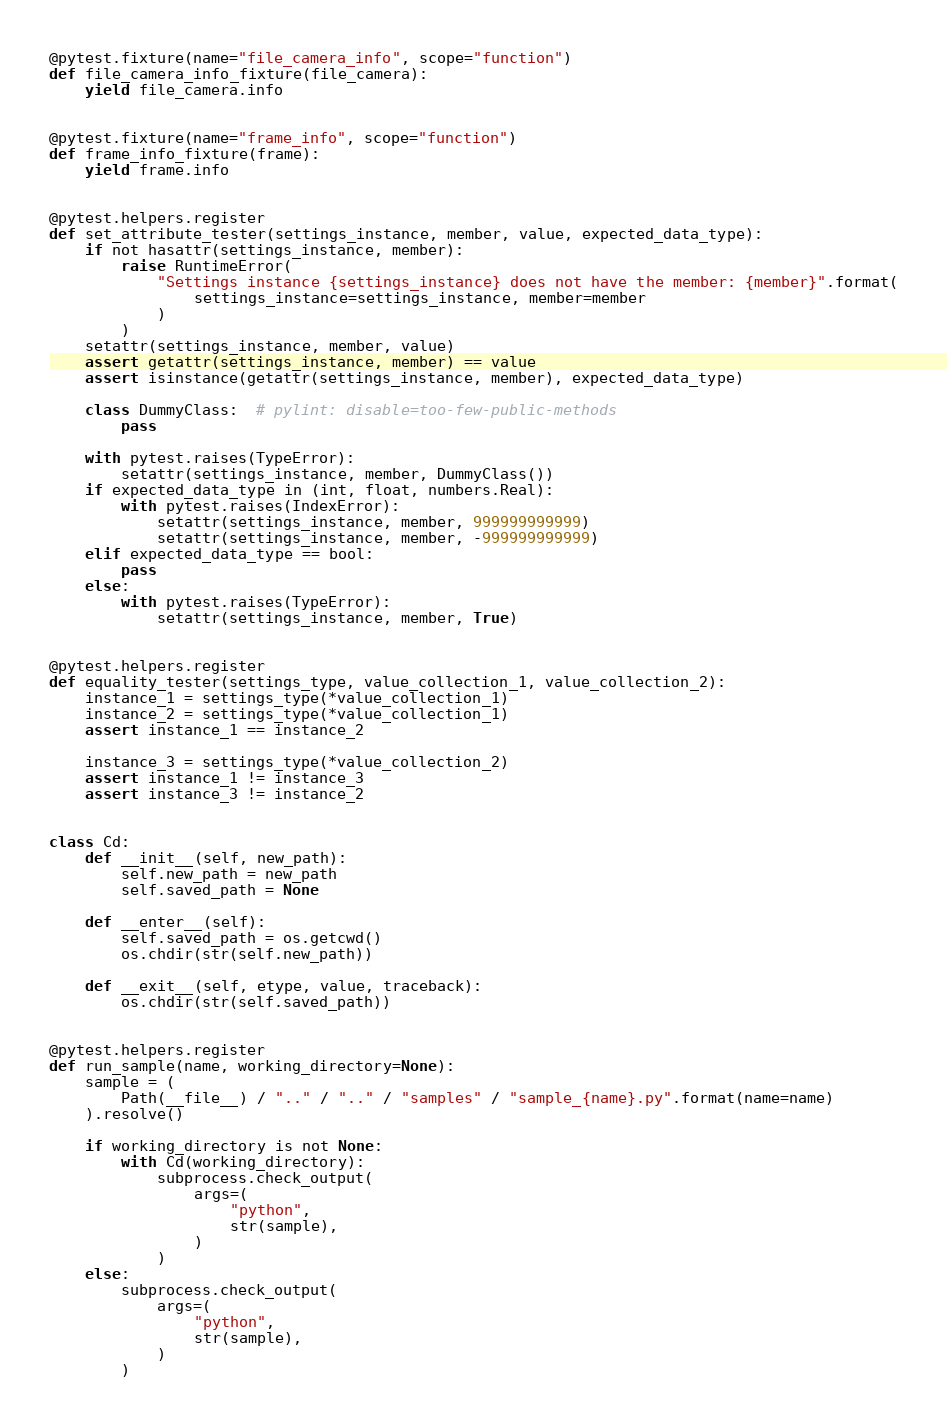Convert code to text. <code><loc_0><loc_0><loc_500><loc_500><_Python_>

@pytest.fixture(name="file_camera_info", scope="function")
def file_camera_info_fixture(file_camera):
    yield file_camera.info


@pytest.fixture(name="frame_info", scope="function")
def frame_info_fixture(frame):
    yield frame.info


@pytest.helpers.register
def set_attribute_tester(settings_instance, member, value, expected_data_type):
    if not hasattr(settings_instance, member):
        raise RuntimeError(
            "Settings instance {settings_instance} does not have the member: {member}".format(
                settings_instance=settings_instance, member=member
            )
        )
    setattr(settings_instance, member, value)
    assert getattr(settings_instance, member) == value
    assert isinstance(getattr(settings_instance, member), expected_data_type)

    class DummyClass:  # pylint: disable=too-few-public-methods
        pass

    with pytest.raises(TypeError):
        setattr(settings_instance, member, DummyClass())
    if expected_data_type in (int, float, numbers.Real):
        with pytest.raises(IndexError):
            setattr(settings_instance, member, 999999999999)
            setattr(settings_instance, member, -999999999999)
    elif expected_data_type == bool:
        pass
    else:
        with pytest.raises(TypeError):
            setattr(settings_instance, member, True)


@pytest.helpers.register
def equality_tester(settings_type, value_collection_1, value_collection_2):
    instance_1 = settings_type(*value_collection_1)
    instance_2 = settings_type(*value_collection_1)
    assert instance_1 == instance_2

    instance_3 = settings_type(*value_collection_2)
    assert instance_1 != instance_3
    assert instance_3 != instance_2


class Cd:
    def __init__(self, new_path):
        self.new_path = new_path
        self.saved_path = None

    def __enter__(self):
        self.saved_path = os.getcwd()
        os.chdir(str(self.new_path))

    def __exit__(self, etype, value, traceback):
        os.chdir(str(self.saved_path))


@pytest.helpers.register
def run_sample(name, working_directory=None):
    sample = (
        Path(__file__) / ".." / ".." / "samples" / "sample_{name}.py".format(name=name)
    ).resolve()

    if working_directory is not None:
        with Cd(working_directory):
            subprocess.check_output(
                args=(
                    "python",
                    str(sample),
                )
            )
    else:
        subprocess.check_output(
            args=(
                "python",
                str(sample),
            )
        )
</code> 